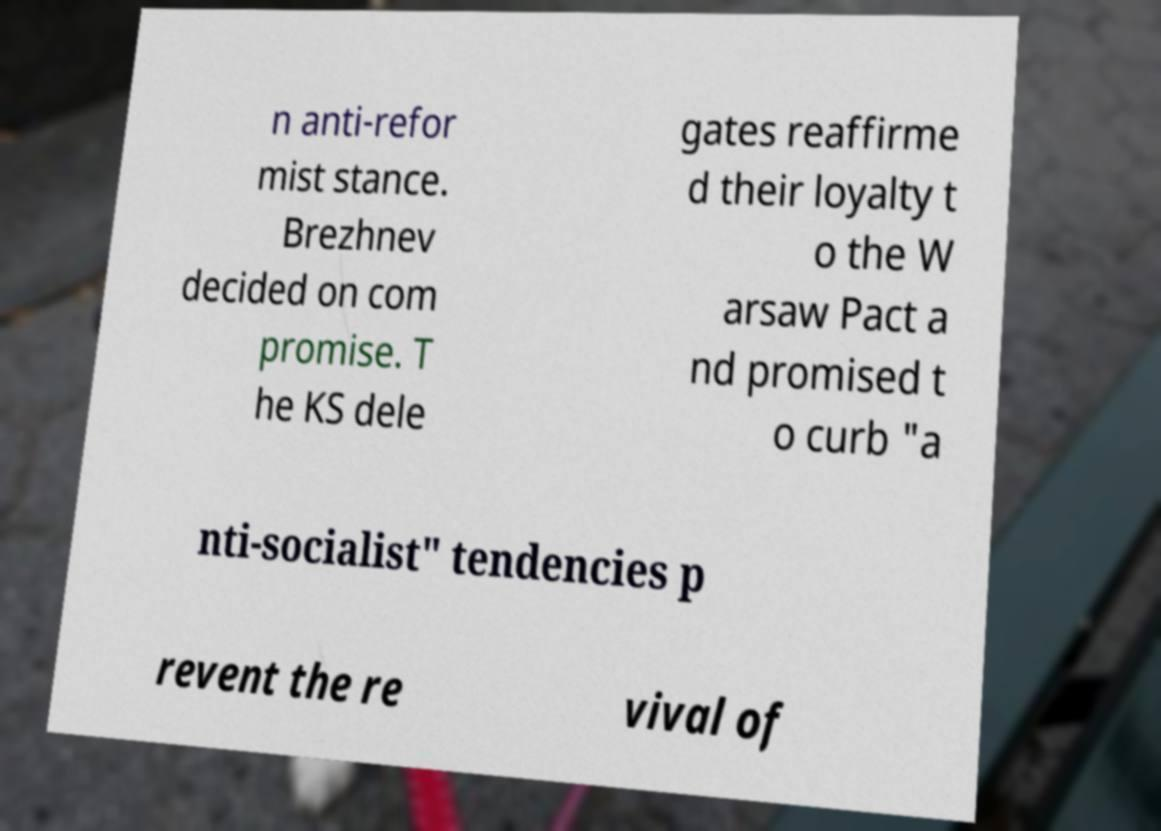Could you extract and type out the text from this image? n anti-refor mist stance. Brezhnev decided on com promise. T he KS dele gates reaffirme d their loyalty t o the W arsaw Pact a nd promised t o curb "a nti-socialist" tendencies p revent the re vival of 